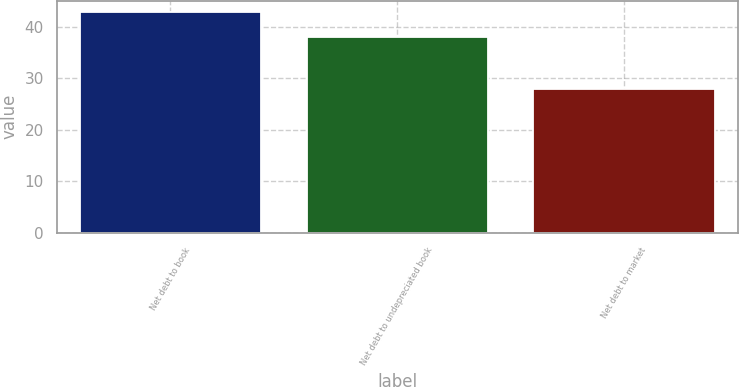Convert chart to OTSL. <chart><loc_0><loc_0><loc_500><loc_500><bar_chart><fcel>Net debt to book<fcel>Net debt to undepreciated book<fcel>Net debt to market<nl><fcel>43<fcel>38<fcel>28<nl></chart> 